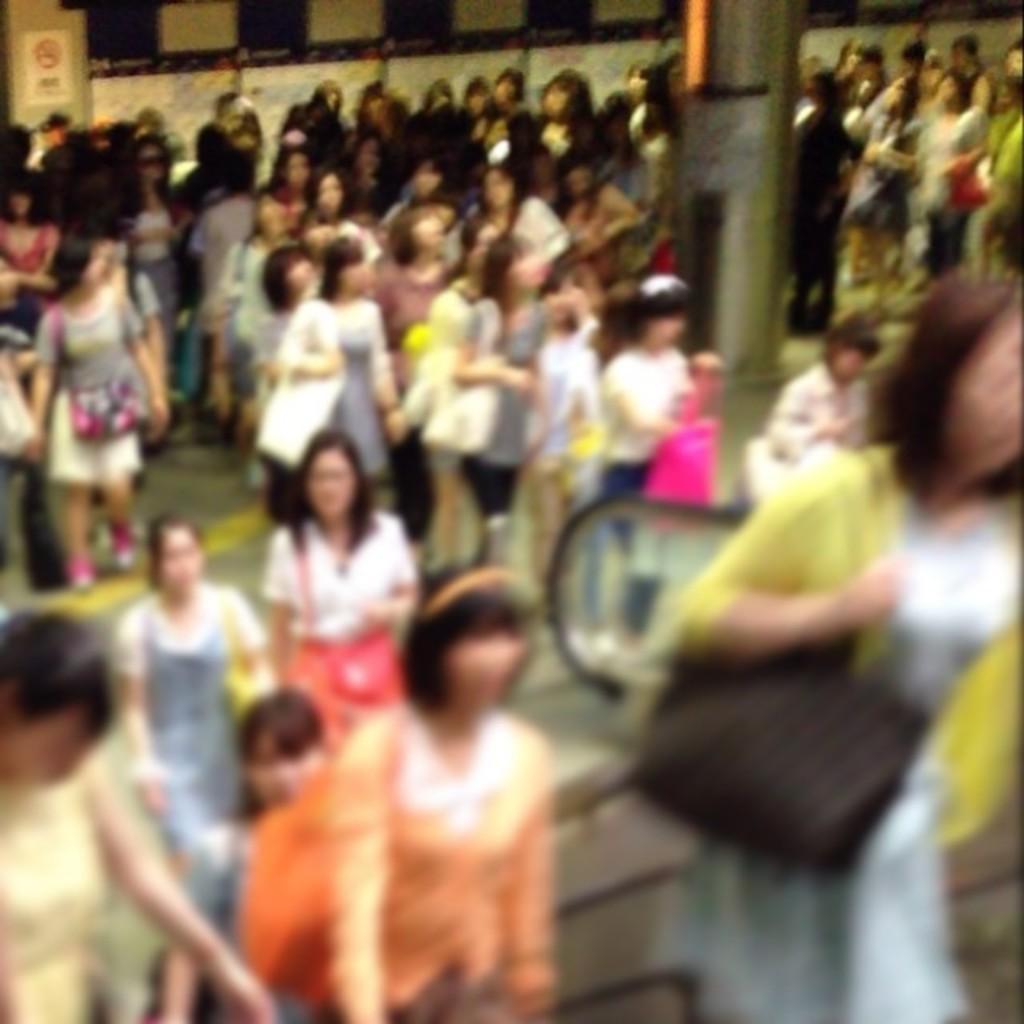Describe this image in one or two sentences. In the image there are many women standing and walking all over the land, on the right side it seems to be an escalator. 